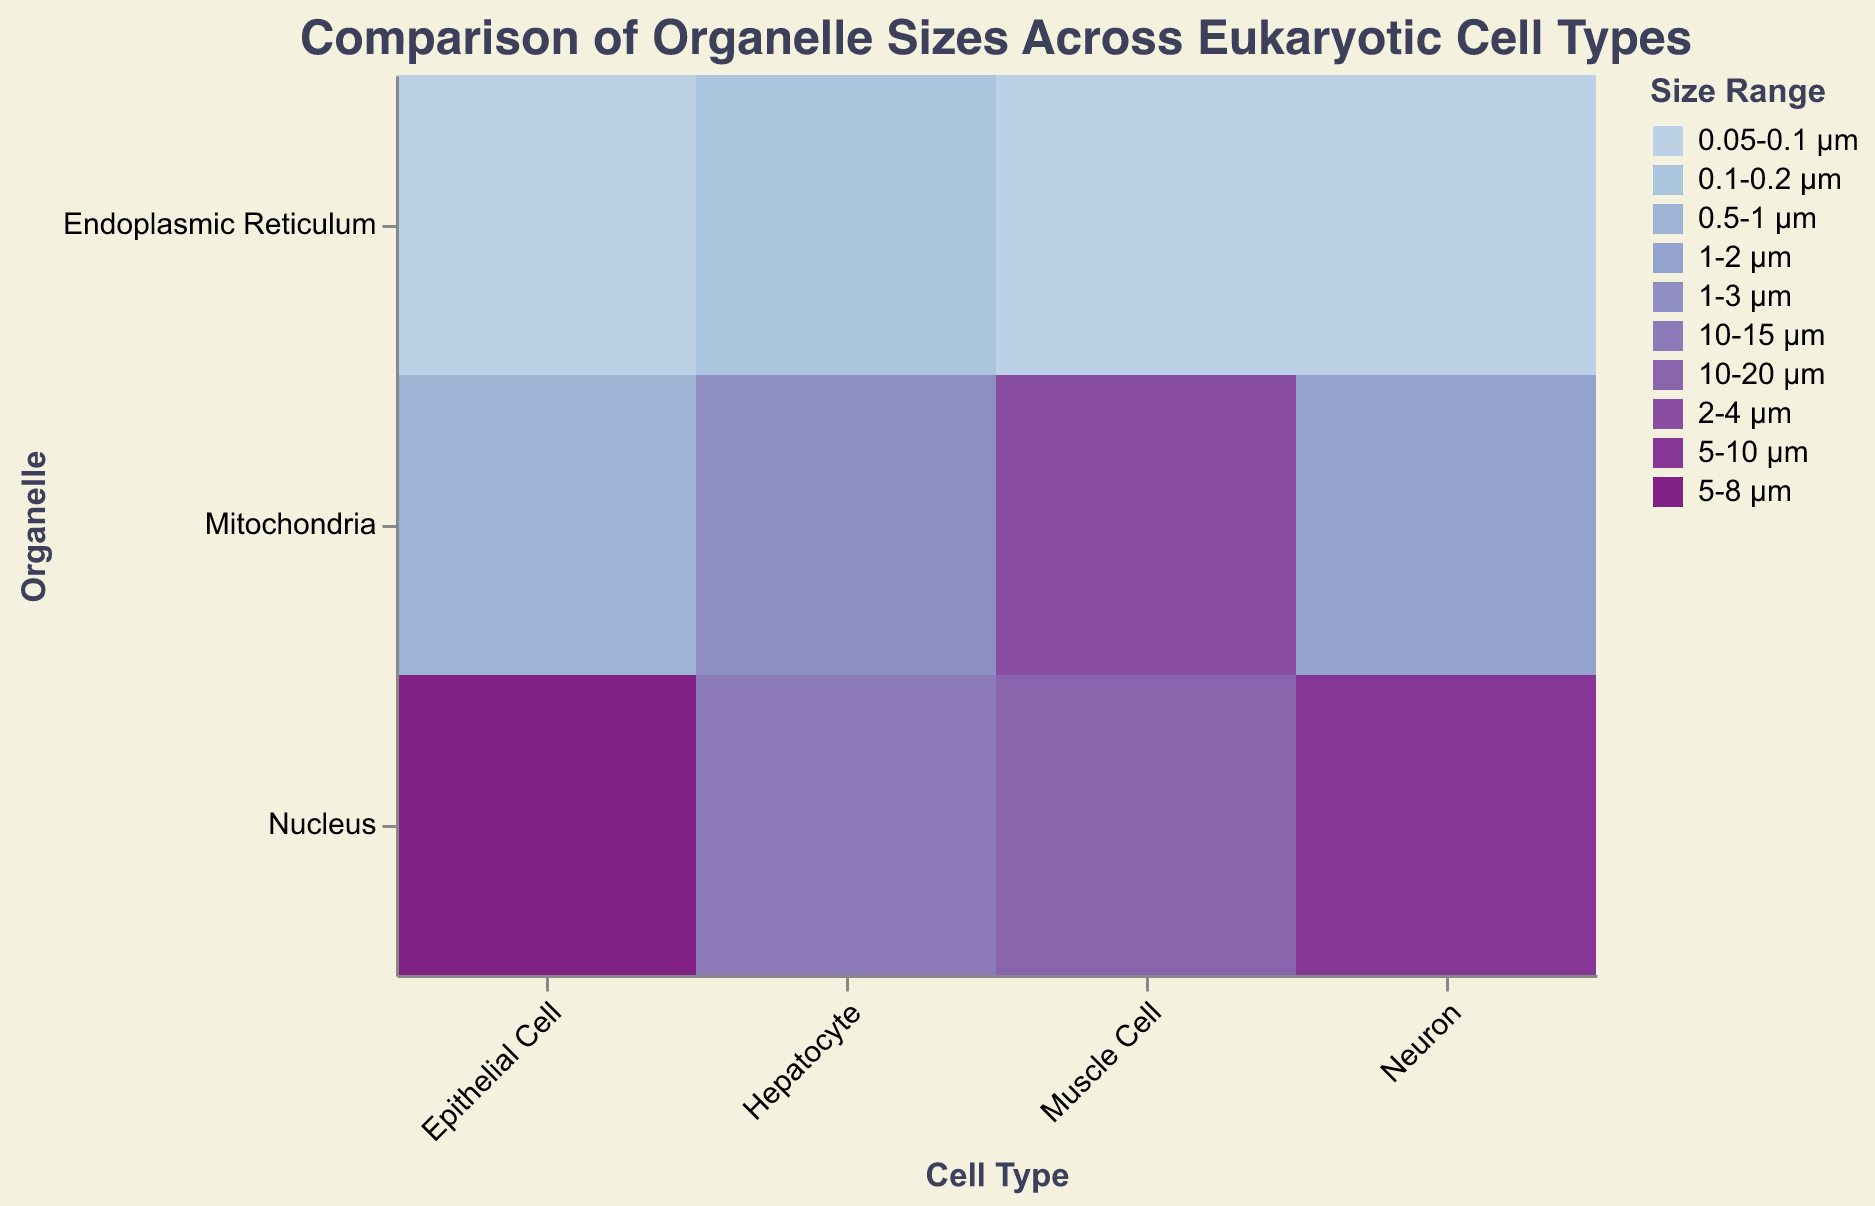Which cell type has the largest size range for the nucleus? The figure indicates the size range of the nucleus for each cell type. By comparing them, the Muscle Cell has a size range of 10-20 µm, which is the largest size range for the nucleus among the given cell types.
Answer: Muscle Cell What is the size range of the mitochondria in Neurons? The plot shows that Neurons have mitochondria with a size range of 1-2 µm.
Answer: 1-2 µm How does the size range of the endoplasmic reticulum in Neurons compare to that in Hepatocytes? The endoplasmic reticulum size range in Neurons is 0.05-0.1 µm, while in Hepatocytes, it is 0.1-0.2 µm. Neurons have a smaller size range for the endoplasmic reticulum compared to Hepatocytes.
Answer: Neurons: 0.05-0.1 µm, Hepatocytes: 0.1-0.2 µm What's the visual representation of the nucleus size range in Epithelial Cells? The figure indicates the nucleus size range in Epithelial Cells as 5-8 µm and marks this with a colored rectangle.
Answer: 5-8 µm Which organelle shows the most variation in size range across different cell types? By examining the size ranges of each organelle across different cell types, the nucleus shows the most variation, ranging from 5-20 µm.
Answer: Nucleus What is the smallest size range for mitochondria amongst all the cell types? The smallest size range for mitochondria can be observed in Epithelial Cells, indicated as 0.5-1 µm in the figure.
Answer: 0.5-1 µm In which cell type is the endoplasmic reticulum consistently showing the same size range, and what is that range? The endoplasmic reticulum in both Neurons and Muscle Cells shows a consistent size range of 0.05-0.1 µm.
Answer: Neurons and Muscle Cells: 0.05-0.1 µm How do the sizes of mitochondria compare in Neurons and Muscle Cells? Neurons have mitochondria with a size range of 1-2 µm, whereas Muscle Cells have mitochondria with a larger size range of 2-4 µm. Thus, Mitochondria in Muscle Cells are generally larger.
Answer: Neurons: 1-2 µm, Muscle Cells: 2-4 µm Which cell type has the most uniform organelle size ranges? Epithelial Cells have the most uniform organelle size ranges, with the nucleus (5-8 µm), mitochondria (0.5-1 µm), and endoplasmic reticulum (0.05-0.1 µm), indicating relatively smaller increments in sizes.
Answer: Epithelial Cells 